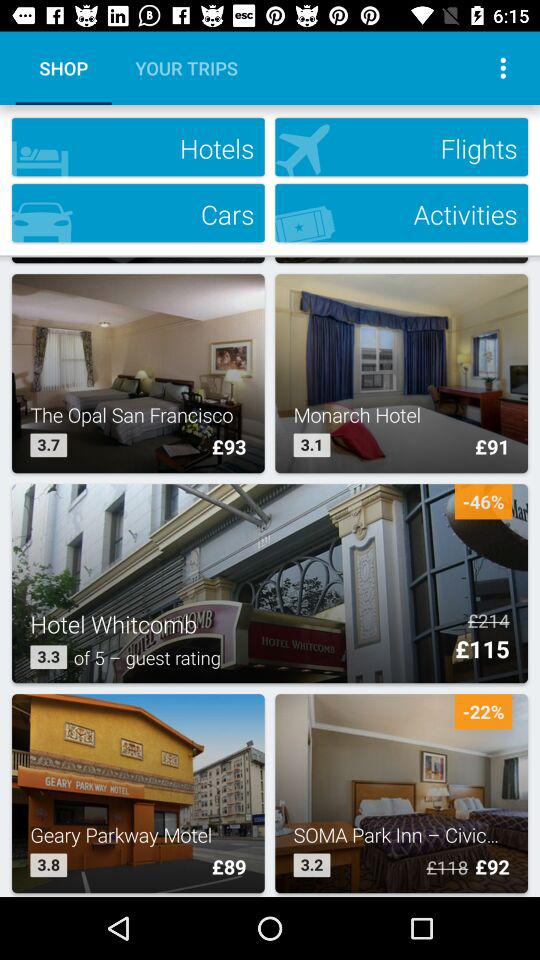What is the after-discount price of a room in the "SOMA Park Inn" hotel? The after-discount price of a room in the "SOMA Park Inn" hotel is £92. 